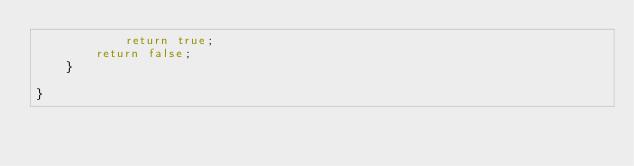<code> <loc_0><loc_0><loc_500><loc_500><_Java_>			return true;		
		return false;
	}

}
</code> 